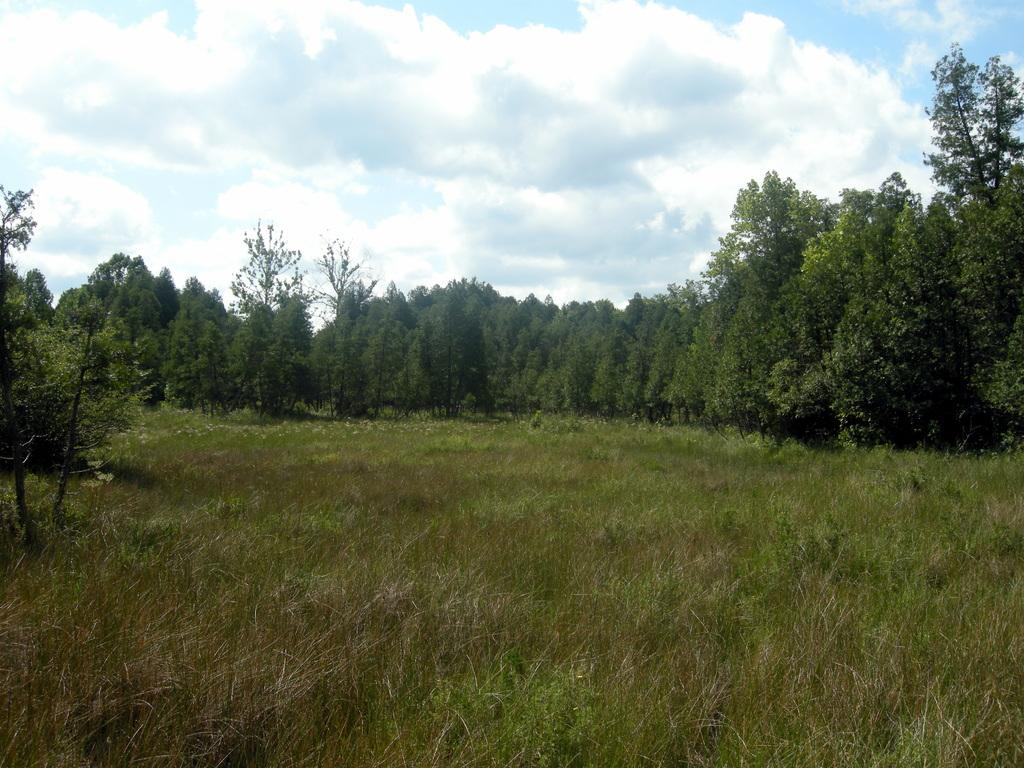What type of vegetation is in the center of the image? There is grass in the center of the image. What can be seen in the background of the image? Sky, clouds, and trees are visible in the background of the image. Can you see any ears in the image? There are no ears visible in the image. 